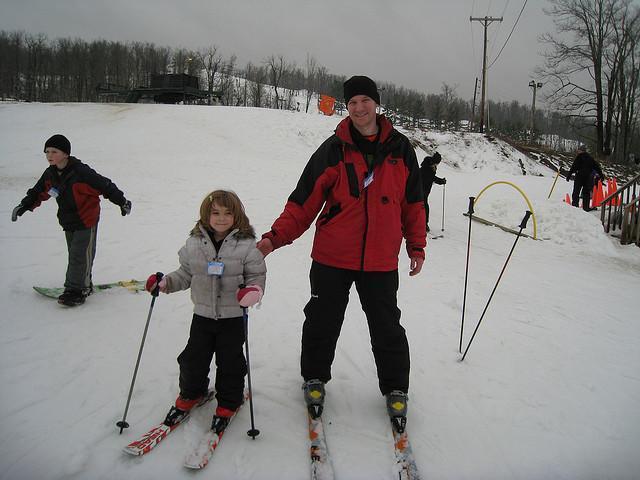How many ski poles is the man physically holding in the picture?
Give a very brief answer. 0. How many people are in the picture?
Give a very brief answer. 4. How many people can you see?
Give a very brief answer. 3. How many bikes are there?
Give a very brief answer. 0. 